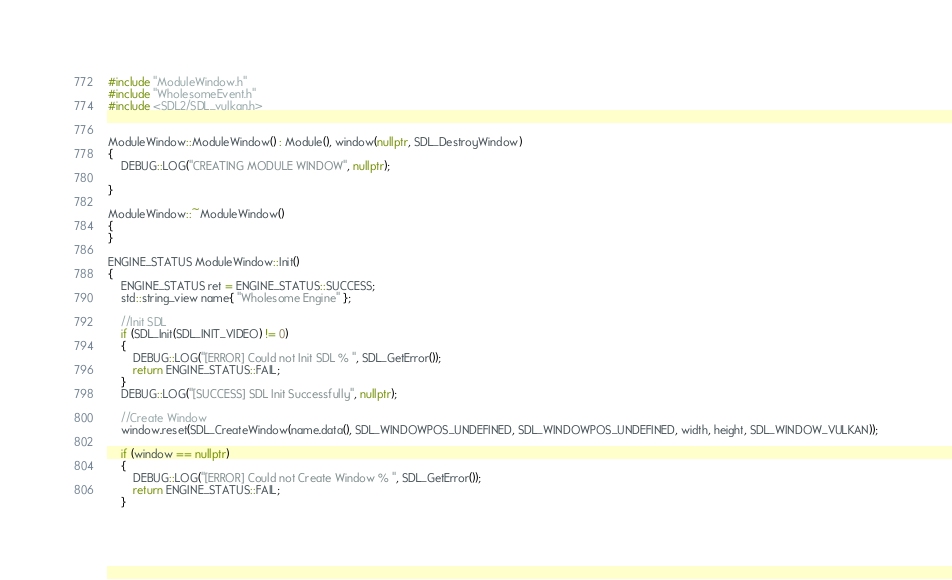<code> <loc_0><loc_0><loc_500><loc_500><_C++_>#include "ModuleWindow.h"
#include "WholesomeEvent.h"
#include <SDL2/SDL_vulkan.h>


ModuleWindow::ModuleWindow() : Module(), window(nullptr, SDL_DestroyWindow)
{
	DEBUG::LOG("CREATING MODULE WINDOW", nullptr);
	
}

ModuleWindow::~ModuleWindow()
{
}

ENGINE_STATUS ModuleWindow::Init()
{
	ENGINE_STATUS ret = ENGINE_STATUS::SUCCESS;
	std::string_view name{ "Wholesome Engine" };

	//Init SDL
	if (SDL_Init(SDL_INIT_VIDEO) != 0)
	{
		DEBUG::LOG("[ERROR] Could not Init SDL % ", SDL_GetError());
		return ENGINE_STATUS::FAIL;
	}
	DEBUG::LOG("[SUCCESS] SDL Init Successfully", nullptr);

	//Create Window
	window.reset(SDL_CreateWindow(name.data(), SDL_WINDOWPOS_UNDEFINED, SDL_WINDOWPOS_UNDEFINED, width, height, SDL_WINDOW_VULKAN));

	if (window == nullptr)
	{
		DEBUG::LOG("[ERROR] Could not Create Window % ", SDL_GetError());
		return ENGINE_STATUS::FAIL;
	}</code> 